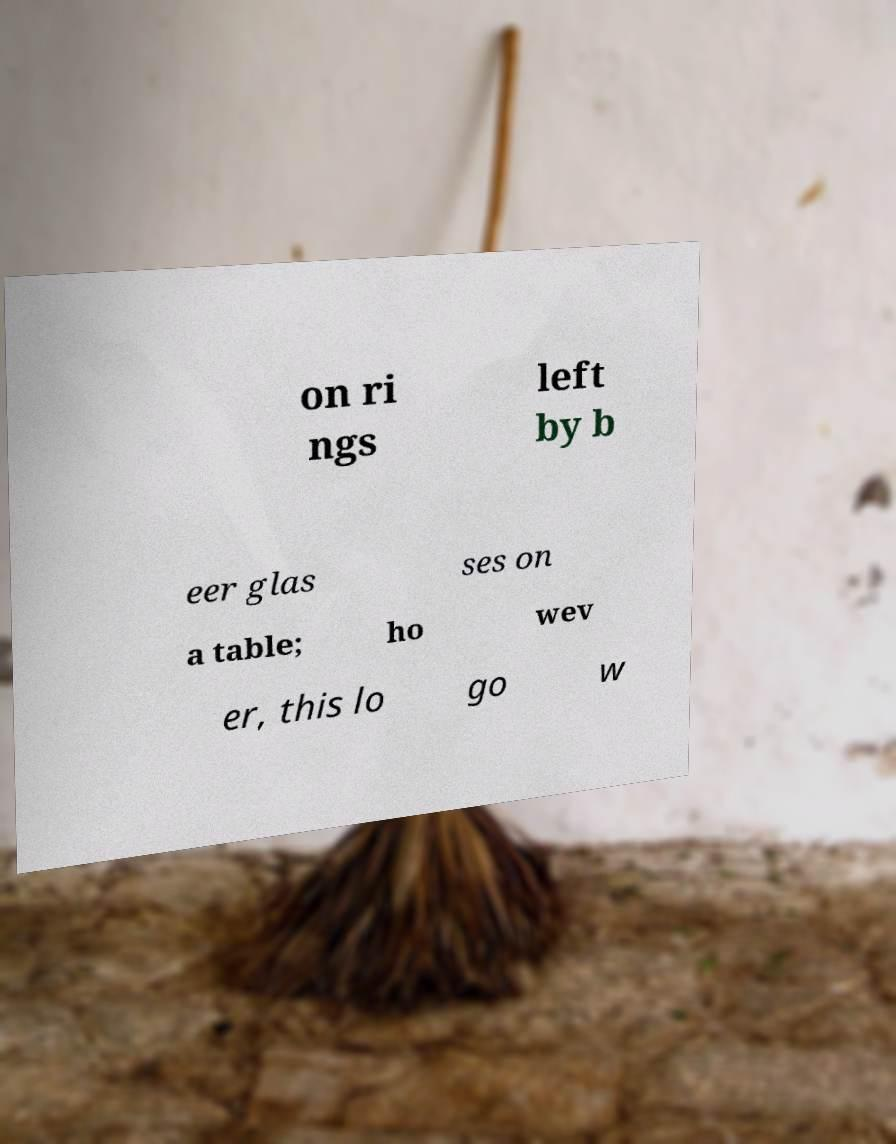For documentation purposes, I need the text within this image transcribed. Could you provide that? on ri ngs left by b eer glas ses on a table; ho wev er, this lo go w 